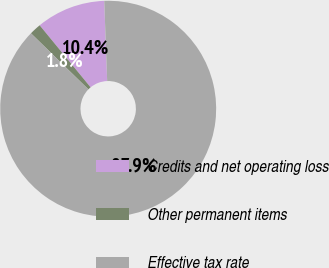<chart> <loc_0><loc_0><loc_500><loc_500><pie_chart><fcel>Credits and net operating loss<fcel>Other permanent items<fcel>Effective tax rate<nl><fcel>10.36%<fcel>1.75%<fcel>87.89%<nl></chart> 